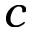<formula> <loc_0><loc_0><loc_500><loc_500>c</formula> 